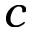<formula> <loc_0><loc_0><loc_500><loc_500>c</formula> 